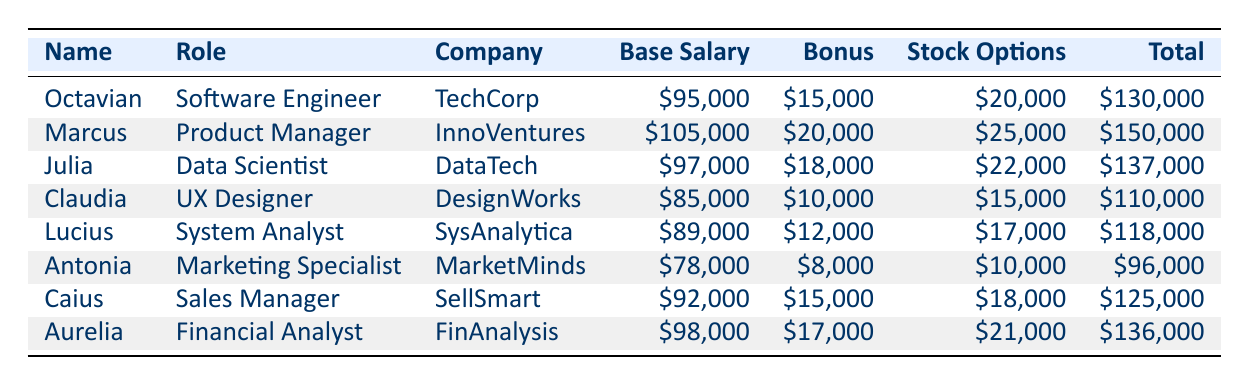What is Octavian's total compensation? According to the table, Octavian's total compensation is listed in the last column as $130,000.
Answer: $130,000 Who has the highest base salary among the peers? By checking the Base Salary column, Marcus has the highest base salary of $105,000 compared to others.
Answer: Marcus What is the difference between Marcus's total compensation and Antonia's total compensation? Marcus's total compensation is $150,000, and Antonia's is $96,000. The difference is $150,000 - $96,000 = $54,000.
Answer: $54,000 Is Claudius's bonus greater than Octavian's bonus? Claudia's bonus is $10,000, while Octavian's bonus is $15,000. Since $10,000 is less than $15,000, this statement is false.
Answer: No What is the average total compensation of all peers? First, we sum the total compensations: $130,000 + $150,000 + $137,000 + $110,000 + $118,000 + $96,000 + $125,000 + $136,000 = $1,012,000. There are 8 peers, so the average is $1,012,000 / 8 = $126,500.
Answer: $126,500 Who are the peers with a total compensation above $120,000? By examining the Total Compensation column, the individuals with totals above $120,000 are Marcus ($150,000), Julia ($137,000), Aurelia ($136,000), and Octavian ($130,000).
Answer: Marcus, Julia, Aurelia, Octavian What roles are represented in the table? The roles in the table include Software Engineer, Product Manager, Data Scientist, UX Designer, System Analyst, Marketing Specialist, Sales Manager, and Financial Analyst.
Answer: Software Engineer, Product Manager, Data Scientist, UX Designer, System Analyst, Marketing Specialist, Sales Manager, Financial Analyst Is Antonia the lowest compensated peer? Antonia has a total compensation of $96,000, which is lower than all others listed. Therefore, this statement is true.
Answer: Yes What is the total base salary of all peers combined? The total base salary is calculated by summing: $95,000 + $105,000 + $97,000 + $85,000 + $89,000 + $78,000 + $92,000 + $98,000 = $839,000.
Answer: $839,000 